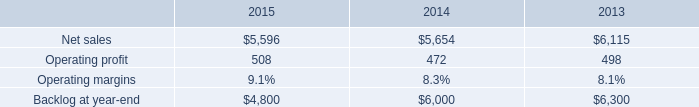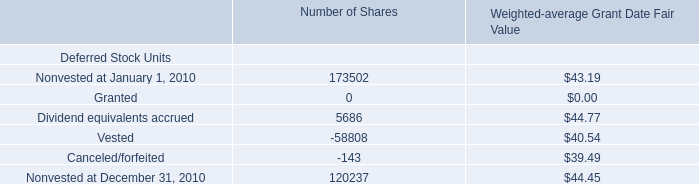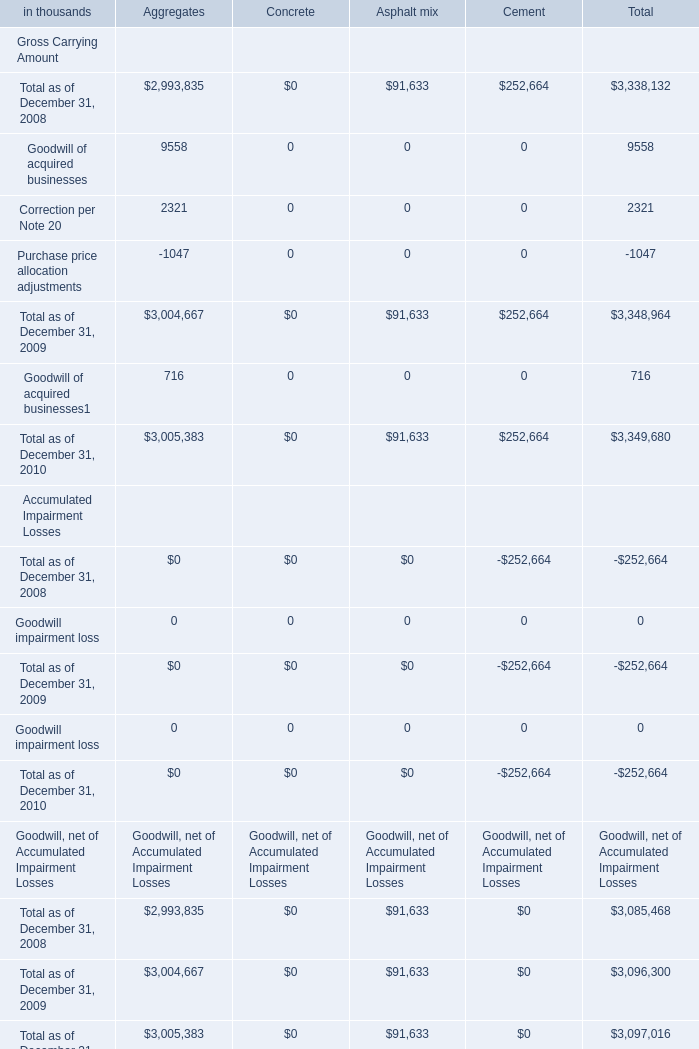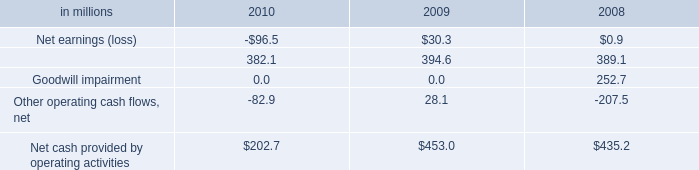What's the average of the Goodwill of acquired businesses for Aggregates in the years where Depreciation, depletion, accretionand amortization is greater than 385? (in thousand) 
Computations: ((9558 + 9558) / 2)
Answer: 9558.0. 